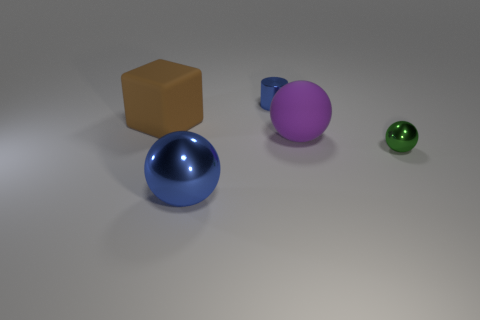What color is the metal object that is both in front of the large brown rubber object and on the left side of the small green shiny ball?
Your answer should be very brief. Blue. Does the large purple ball have the same material as the blue ball?
Your response must be concise. No. What is the shape of the large purple thing?
Ensure brevity in your answer.  Sphere. There is a blue object that is in front of the sphere right of the purple thing; how many blue metallic objects are behind it?
Your response must be concise. 1. What color is the other large metal thing that is the same shape as the green metallic object?
Offer a very short reply. Blue. The metallic object that is behind the big object to the left of the metallic thing in front of the green thing is what shape?
Ensure brevity in your answer.  Cylinder. What is the size of the object that is behind the purple rubber object and on the right side of the big brown matte cube?
Ensure brevity in your answer.  Small. Are there fewer tiny red matte cylinders than small green objects?
Keep it short and to the point. Yes. There is a metal cylinder that is behind the small green metallic object; what is its size?
Make the answer very short. Small. What shape is the big object that is on the left side of the purple object and behind the green sphere?
Provide a short and direct response. Cube. 